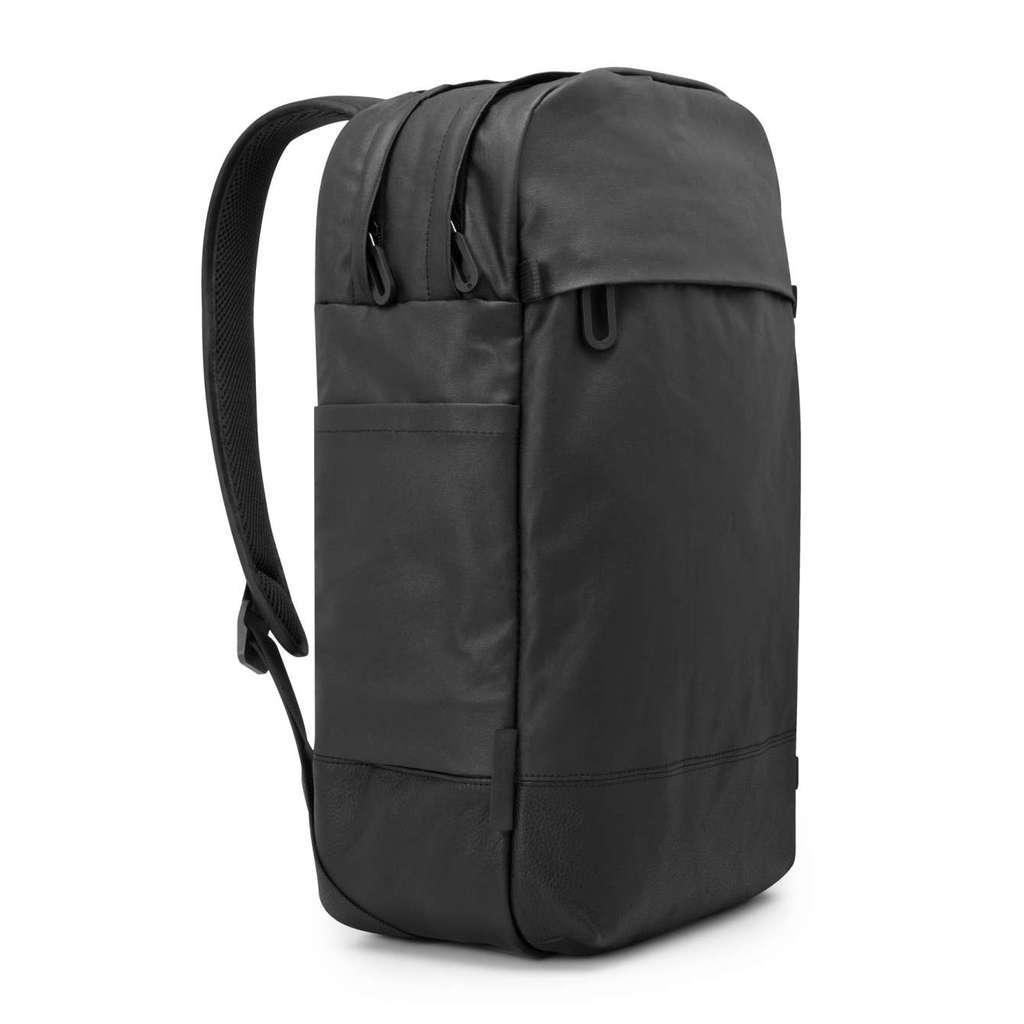Could you give a brief overview of what you see in this image? In this picture we can see a backpack placed on the surface and the background we can see is white in color. 